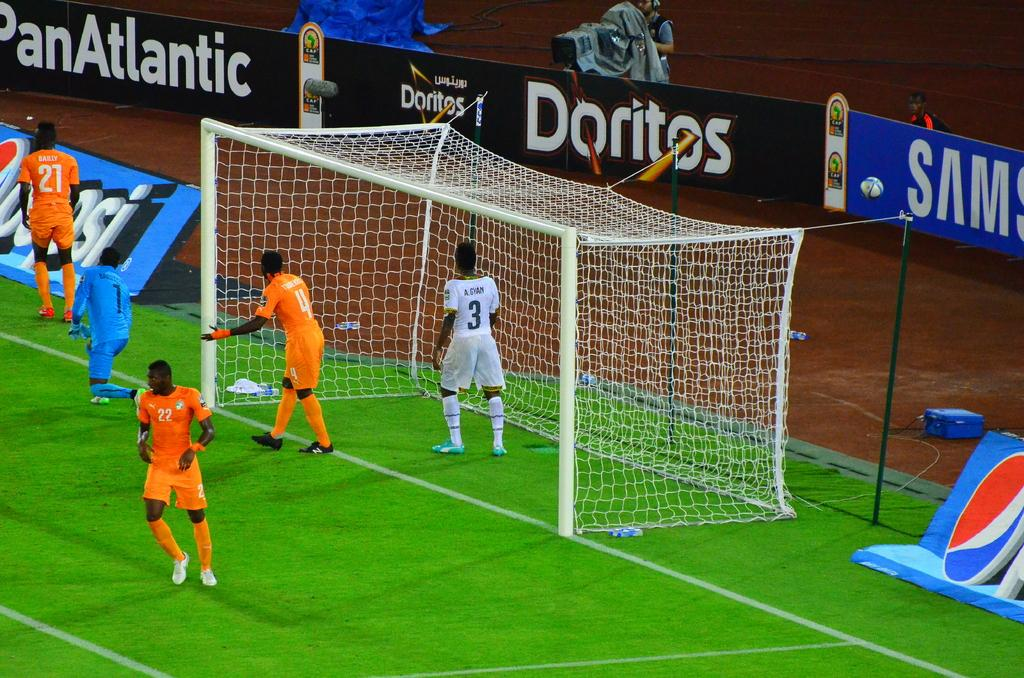<image>
Write a terse but informative summary of the picture. Soccer players on a field with a Doritos advertisement brhind. 